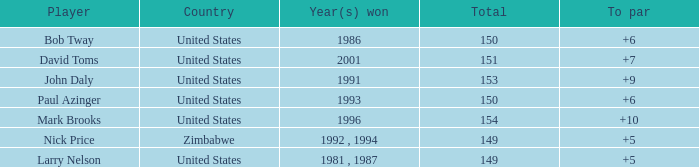Which player won in 1993? Paul Azinger. Would you be able to parse every entry in this table? {'header': ['Player', 'Country', 'Year(s) won', 'Total', 'To par'], 'rows': [['Bob Tway', 'United States', '1986', '150', '+6'], ['David Toms', 'United States', '2001', '151', '+7'], ['John Daly', 'United States', '1991', '153', '+9'], ['Paul Azinger', 'United States', '1993', '150', '+6'], ['Mark Brooks', 'United States', '1996', '154', '+10'], ['Nick Price', 'Zimbabwe', '1992 , 1994', '149', '+5'], ['Larry Nelson', 'United States', '1981 , 1987', '149', '+5']]} 